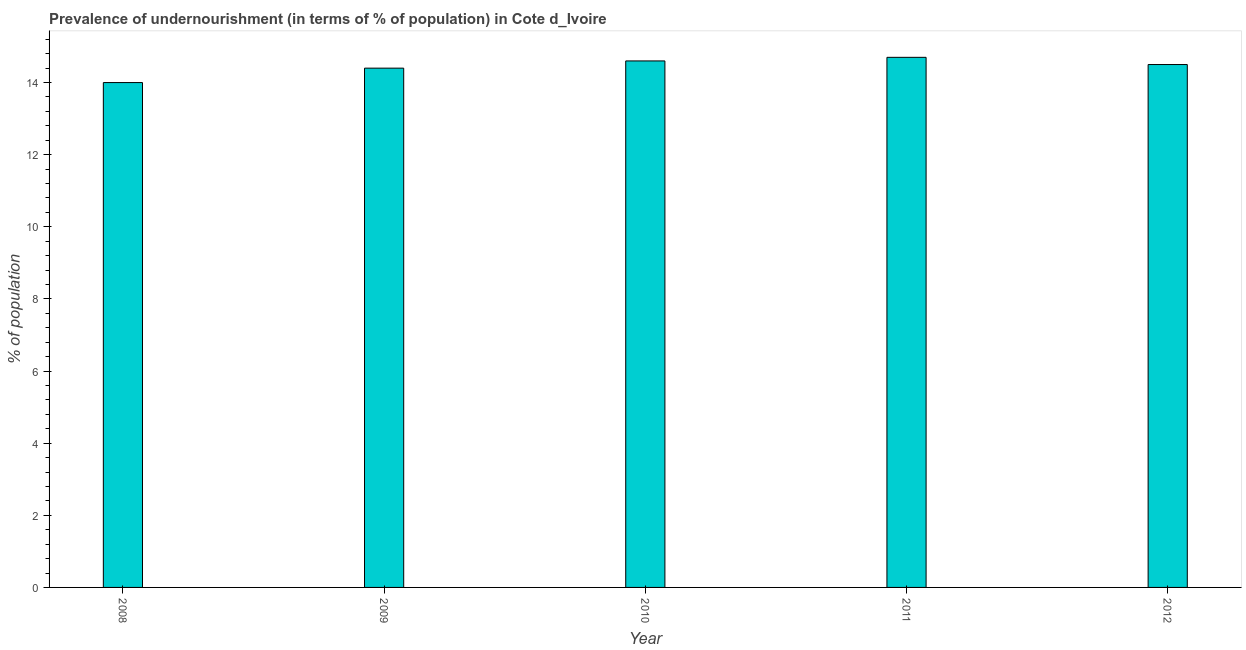Does the graph contain any zero values?
Offer a terse response. No. What is the title of the graph?
Ensure brevity in your answer.  Prevalence of undernourishment (in terms of % of population) in Cote d_Ivoire. What is the label or title of the Y-axis?
Make the answer very short. % of population. What is the percentage of undernourished population in 2011?
Provide a short and direct response. 14.7. Across all years, what is the maximum percentage of undernourished population?
Offer a very short reply. 14.7. What is the sum of the percentage of undernourished population?
Offer a very short reply. 72.2. What is the average percentage of undernourished population per year?
Offer a very short reply. 14.44. What is the median percentage of undernourished population?
Give a very brief answer. 14.5. What is the ratio of the percentage of undernourished population in 2008 to that in 2009?
Offer a very short reply. 0.97. Is the percentage of undernourished population in 2010 less than that in 2011?
Your answer should be compact. Yes. Is the sum of the percentage of undernourished population in 2008 and 2010 greater than the maximum percentage of undernourished population across all years?
Give a very brief answer. Yes. What is the difference between the highest and the lowest percentage of undernourished population?
Your answer should be compact. 0.7. In how many years, is the percentage of undernourished population greater than the average percentage of undernourished population taken over all years?
Your answer should be compact. 3. Are all the bars in the graph horizontal?
Ensure brevity in your answer.  No. How many years are there in the graph?
Offer a terse response. 5. What is the % of population in 2008?
Your answer should be very brief. 14. What is the % of population of 2010?
Offer a terse response. 14.6. What is the % of population in 2012?
Your response must be concise. 14.5. What is the difference between the % of population in 2008 and 2011?
Your answer should be compact. -0.7. What is the difference between the % of population in 2009 and 2012?
Your answer should be very brief. -0.1. What is the difference between the % of population in 2010 and 2011?
Provide a succinct answer. -0.1. What is the difference between the % of population in 2010 and 2012?
Make the answer very short. 0.1. What is the ratio of the % of population in 2008 to that in 2011?
Ensure brevity in your answer.  0.95. What is the ratio of the % of population in 2008 to that in 2012?
Offer a terse response. 0.97. What is the ratio of the % of population in 2009 to that in 2010?
Provide a short and direct response. 0.99. What is the ratio of the % of population in 2009 to that in 2011?
Your answer should be compact. 0.98. What is the ratio of the % of population in 2009 to that in 2012?
Your answer should be compact. 0.99. What is the ratio of the % of population in 2010 to that in 2012?
Make the answer very short. 1.01. What is the ratio of the % of population in 2011 to that in 2012?
Provide a succinct answer. 1.01. 